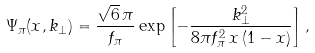Convert formula to latex. <formula><loc_0><loc_0><loc_500><loc_500>\Psi _ { \pi } ( x , { k } _ { \perp } ) = \frac { \sqrt { 6 } \, \pi } { f _ { \pi } } \exp \left [ - \frac { k _ { \perp } ^ { 2 } } { 8 \pi f _ { \pi } ^ { 2 } \, x \, ( 1 - x ) } \right ] ,</formula> 